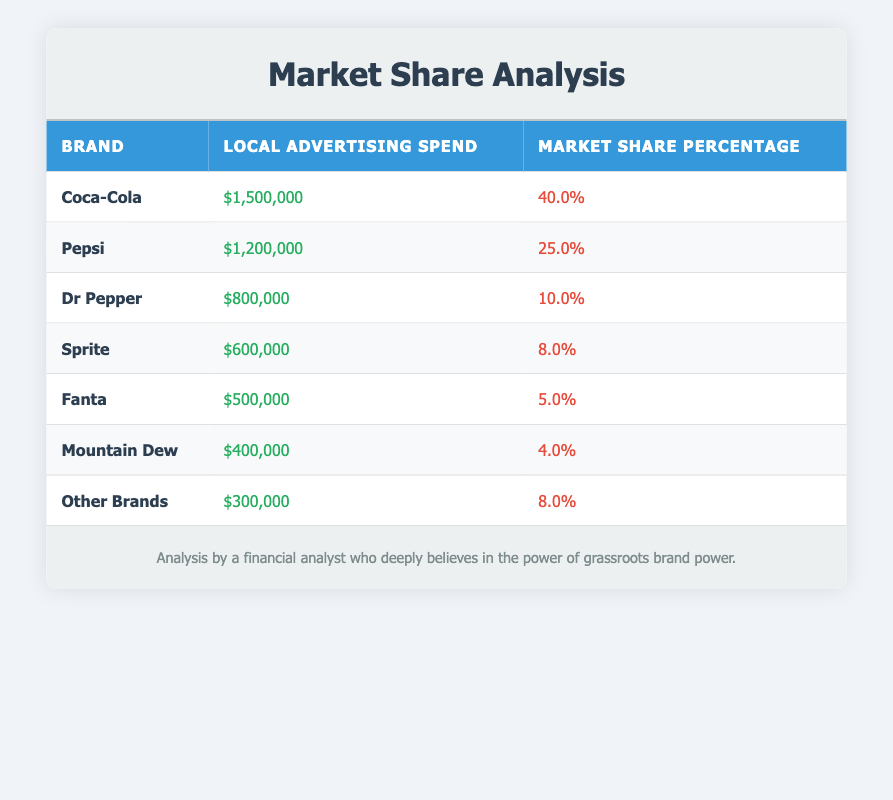What is the market share percentage of Coca-Cola? The table shows that Coca-Cola has a market share percentage listed directly in its row. The value is 40.0%.
Answer: 40.0% How much did Pepsi spend on local advertising? According to the table, Pepsi's local advertising spend is listed under its row as $1,200,000.
Answer: $1,200,000 Which brand has the lowest market share percentage? By examining the market share percentages in the table, Mountain Dew has the lowest percentage at 4.0%, as it is the smallest value among the entries.
Answer: Mountain Dew What is the total local advertising spend for Coca-Cola and Pepsi combined? To find the total, I add Coca-Cola's spend ($1,500,000) with Pepsi's spend ($1,200,000): $1,500,000 + $1,200,000 = $2,700,000.
Answer: $2,700,000 Is it true that Sprite has a higher market share percentage than Fanta? Comparing the market share percentages, Sprite is at 8.0% and Fanta is at 5.0%. Since 8.0% is greater than 5.0%, the statement is true.
Answer: Yes What is the average local advertising spend of the brands listed? First, I calculate the total local advertising spend: $1,500,000 + $1,200,000 + $800,000 + $600,000 + $500,000 + $400,000 + $300,000 = $5,300,000. There are 7 brands, so the average is $5,300,000 / 7 = $757,142.86; rounding gives approximately $757,143.
Answer: $757,143 If we combine the market share percentages of 'Other Brands' with that of Dr Pepper, what do we get? I locate Dr Pepper's market share (10.0%) and 'Other Brands' (8.0%). Adding them gives: 10.0% + 8.0% = 18.0%.
Answer: 18.0% Which brand has a local advertising spend of less than $600,000? Looking at the table, both Mountain Dew ($400,000) and Other Brands ($300,000) have spends less than $600,000, confirming this statement is accurate.
Answer: Mountain Dew, Other Brands What market share percentage do Dr Pepper and Sprite have in total? To assess this, I find Dr Pepper’s market share (10.0%) and Sprite’s market share (8.0%) and add them: 10.0% + 8.0% = 18.0%.
Answer: 18.0% 